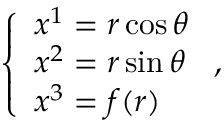Convert formula to latex. <formula><loc_0><loc_0><loc_500><loc_500>\left \{ \begin{array} { l } { x ^ { 1 } = r \cos { \theta } } \\ { x ^ { 2 } = r \sin { \theta } } \\ { x ^ { 3 } = f ( r ) } \end{array} ,</formula> 